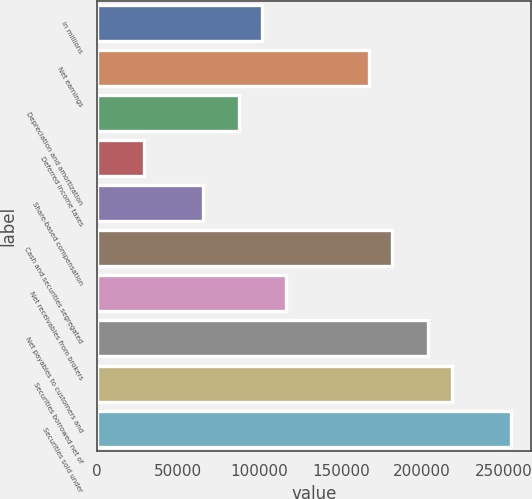Convert chart to OTSL. <chart><loc_0><loc_0><loc_500><loc_500><bar_chart><fcel>in millions<fcel>Net earnings<fcel>Depreciation and amortization<fcel>Deferred income taxes<fcel>Share-based compensation<fcel>Cash and securities segregated<fcel>Net receivables from brokers<fcel>Net payables to customers and<fcel>Securities borrowed net of<fcel>Securities sold under<nl><fcel>101736<fcel>167137<fcel>87202.6<fcel>29068.2<fcel>65402.2<fcel>181671<fcel>116270<fcel>203471<fcel>218005<fcel>254339<nl></chart> 